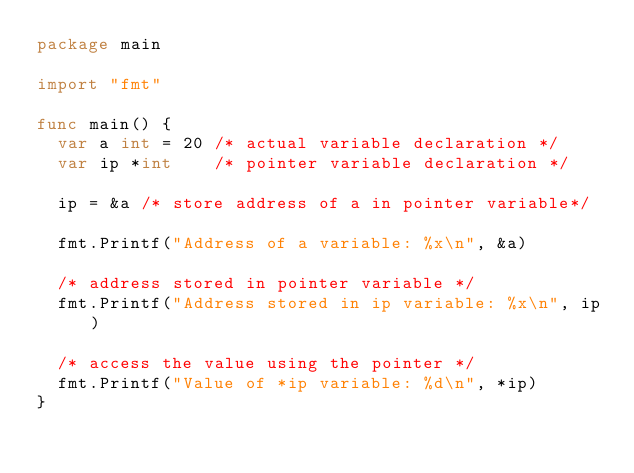<code> <loc_0><loc_0><loc_500><loc_500><_Go_>package main

import "fmt"

func main() {
	var a int = 20 /* actual variable declaration */
	var ip *int    /* pointer variable declaration */

	ip = &a /* store address of a in pointer variable*/

	fmt.Printf("Address of a variable: %x\n", &a)

	/* address stored in pointer variable */
	fmt.Printf("Address stored in ip variable: %x\n", ip)

	/* access the value using the pointer */
	fmt.Printf("Value of *ip variable: %d\n", *ip)
}
</code> 